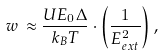Convert formula to latex. <formula><loc_0><loc_0><loc_500><loc_500>w \, \approx \frac { U E _ { 0 } \Delta } { k _ { B } T } \cdot \left ( \frac { 1 } { E _ { e x t } ^ { 2 } } \right ) ,</formula> 